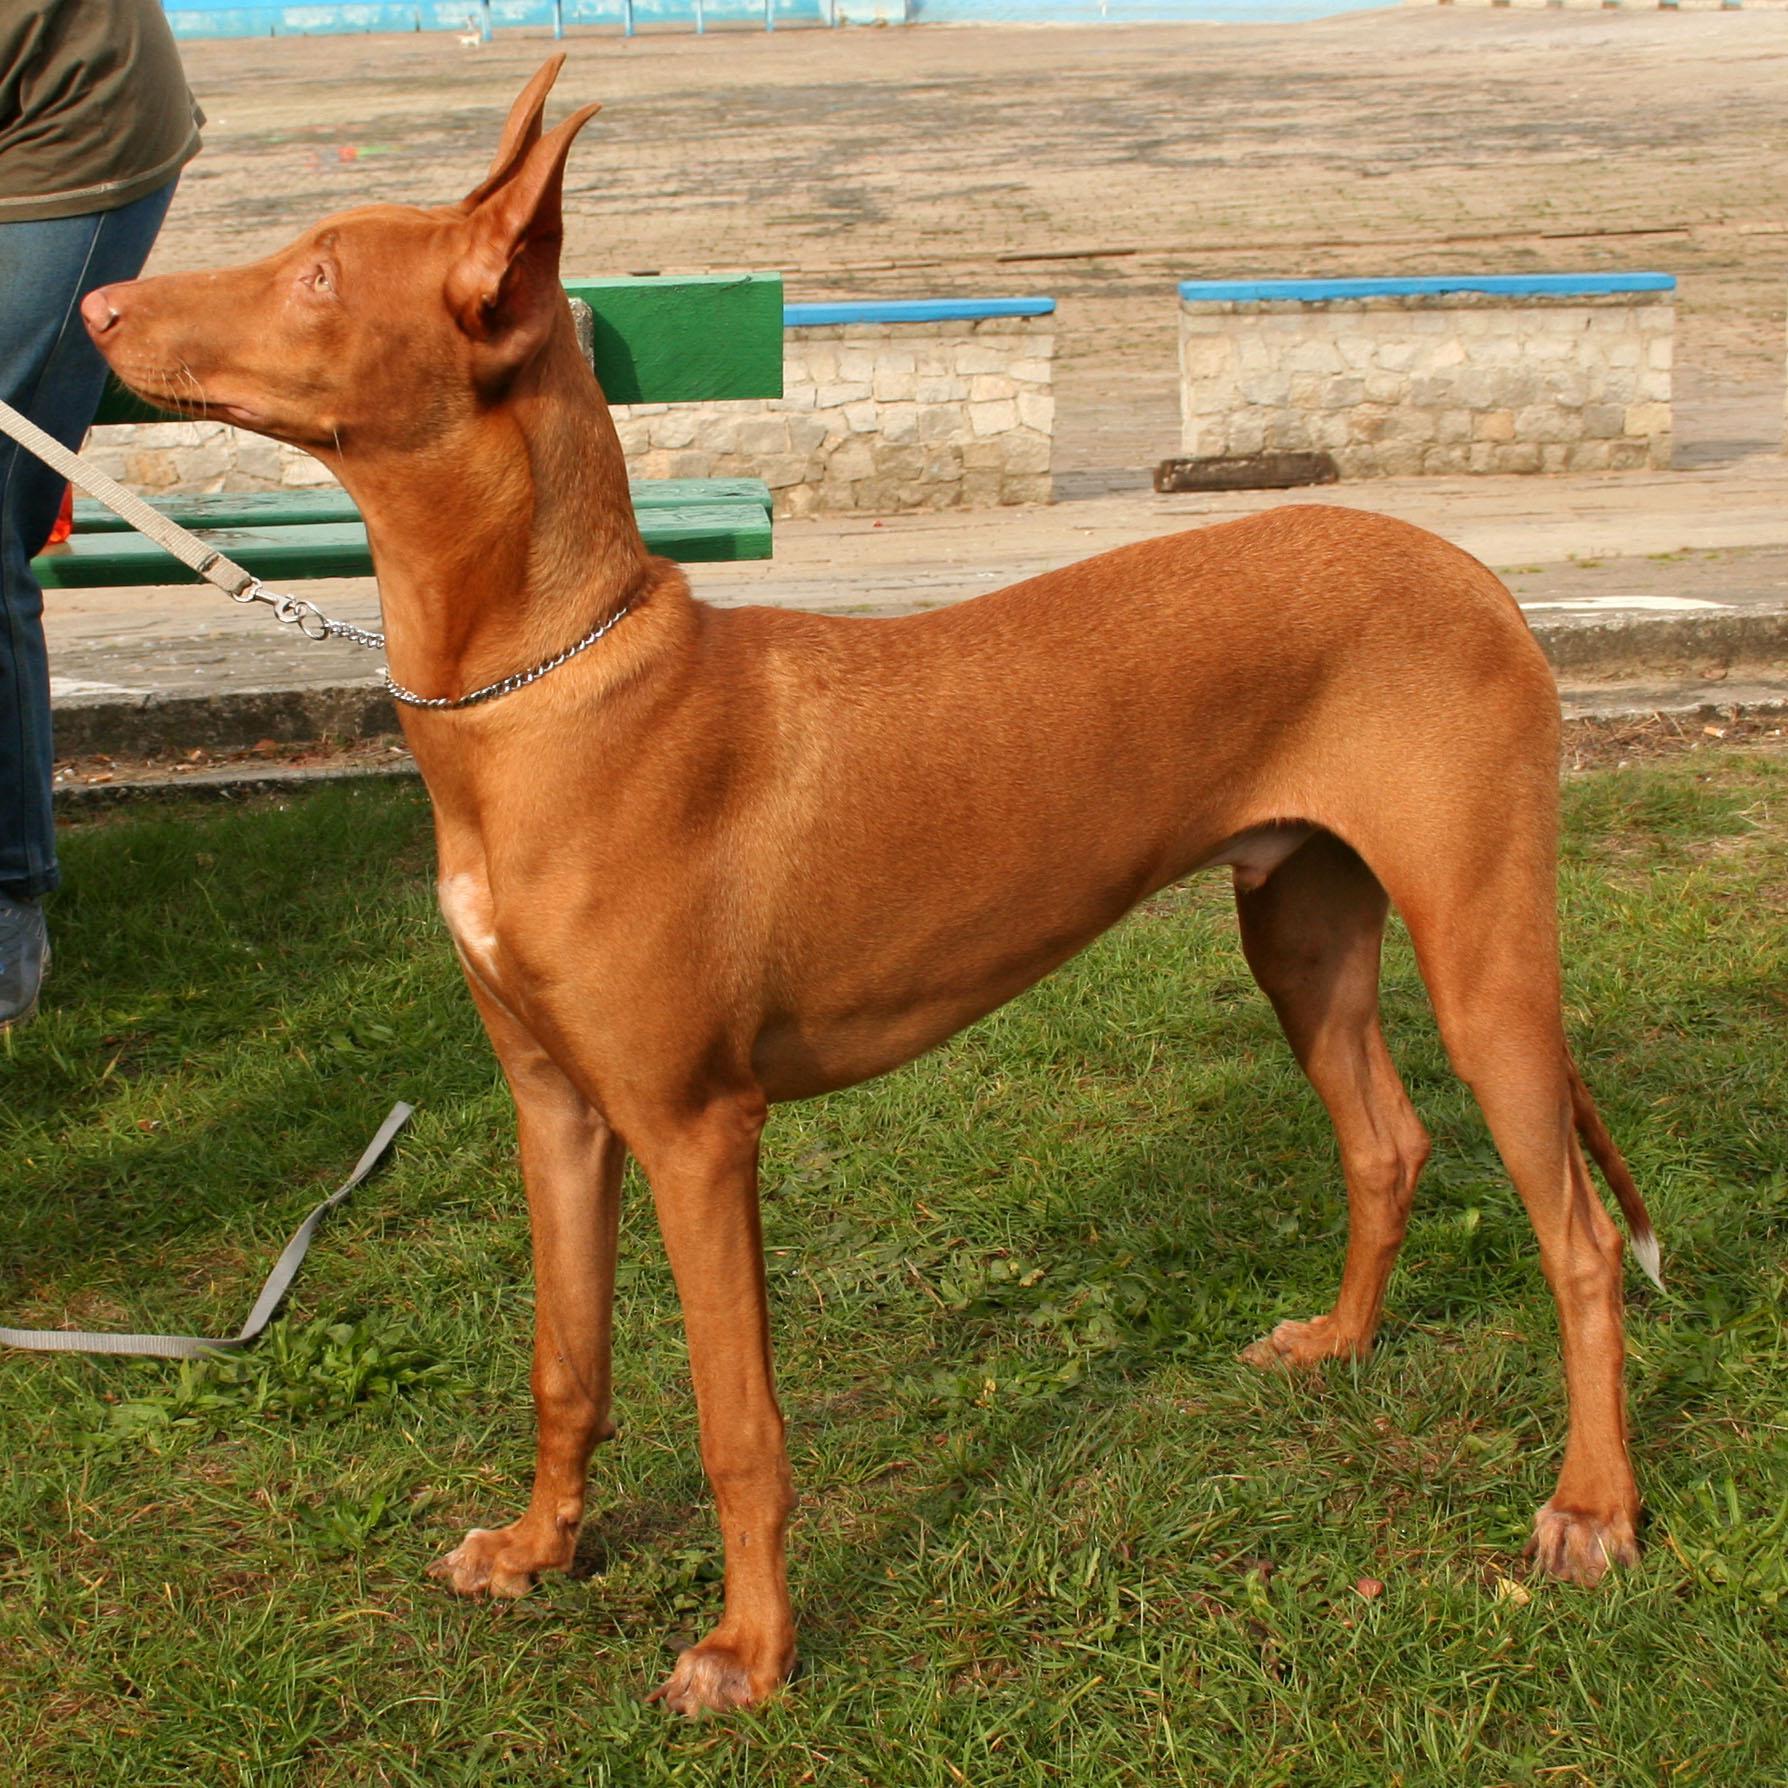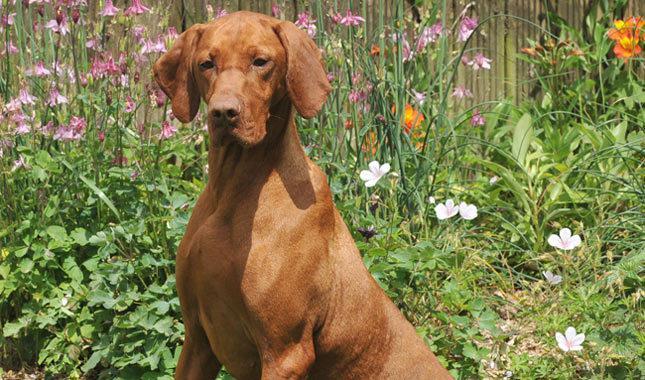The first image is the image on the left, the second image is the image on the right. Examine the images to the left and right. Is the description "The dog in each of the images is standing up on all four." accurate? Answer yes or no. No. 